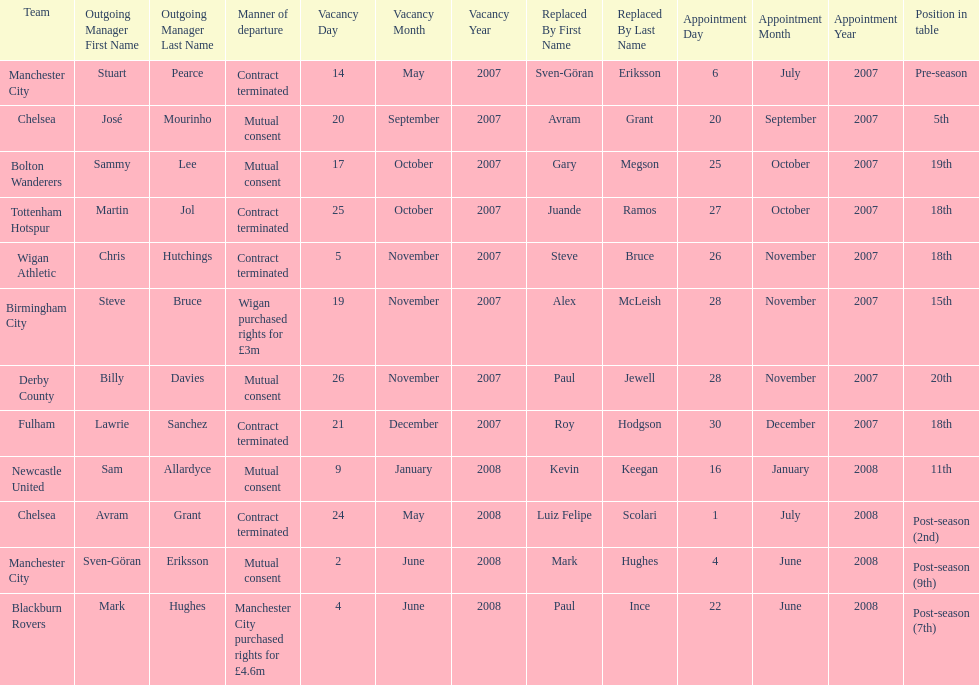How many teams had a manner of departure due to there contract being terminated? 5. 